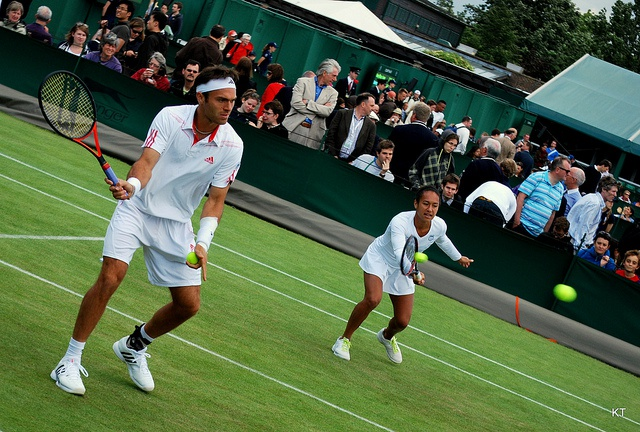Describe the objects in this image and their specific colors. I can see people in lightgray, black, gray, brown, and maroon tones, people in lavender, lightgray, darkgray, lightblue, and maroon tones, people in lightgray, black, maroon, and lightblue tones, tennis racket in lightgray, black, gray, olive, and darkgreen tones, and people in lightgray, darkgray, gray, and black tones in this image. 